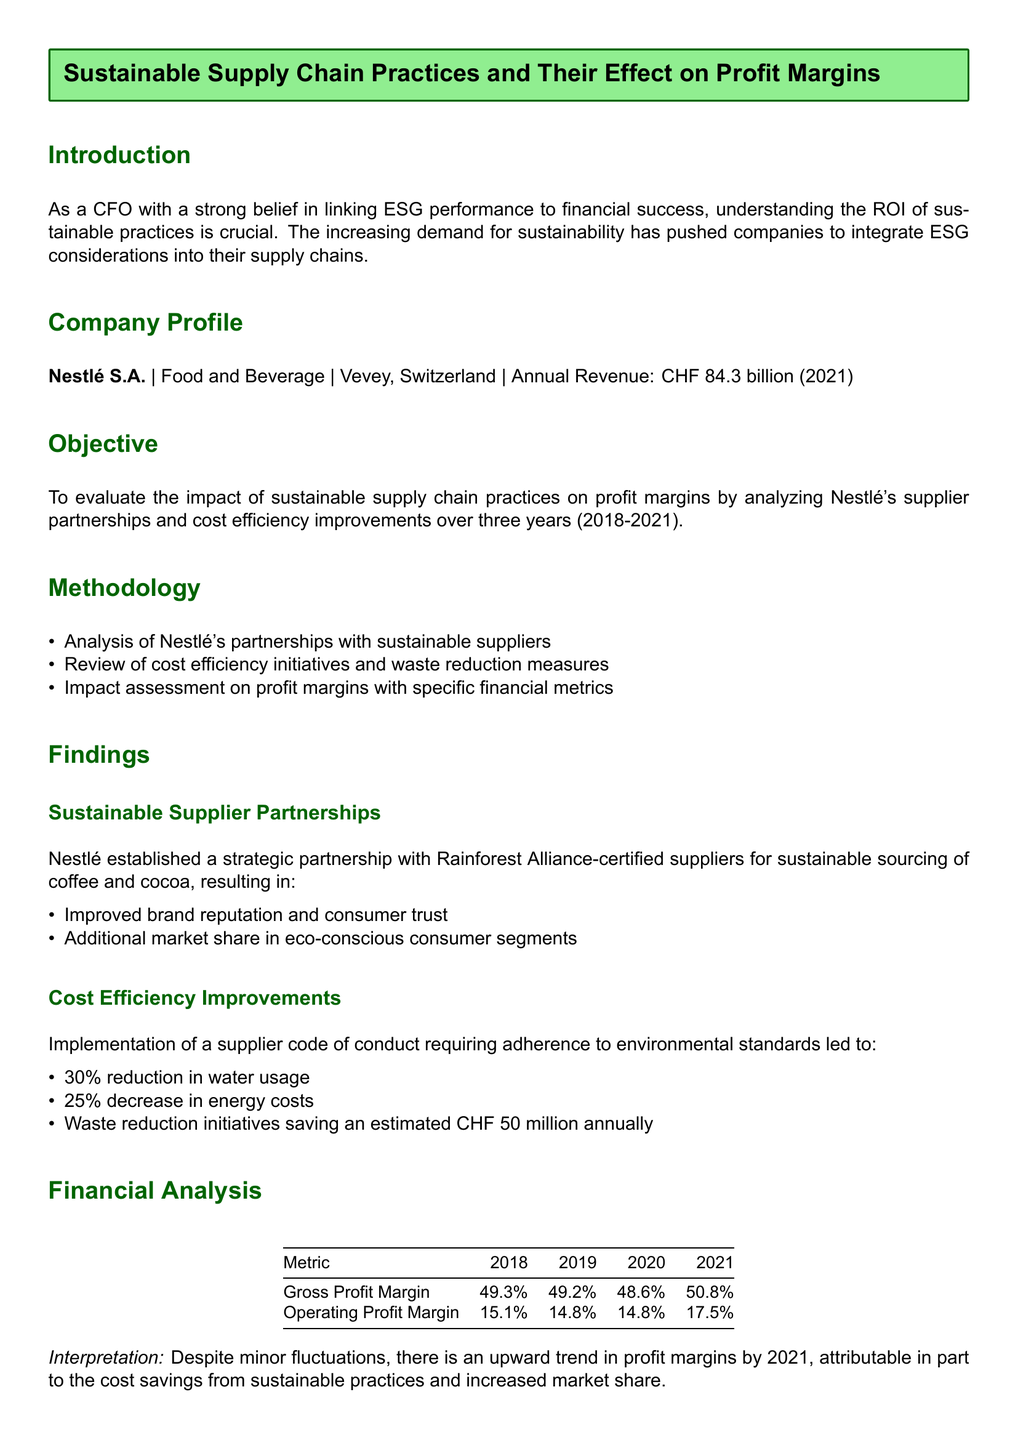What is the annual revenue of Nestlé in 2021? The document states the annual revenue of Nestlé in 2021 as CHF 84.3 billion.
Answer: CHF 84.3 billion What year marks the start of the evaluation period? The evaluation period for the impact of sustainable supply chain practices starts in 2018.
Answer: 2018 What percentage was the gross profit margin in 2021? The gross profit margin in 2021 is presented as 50.8%.
Answer: 50.8% What initiative led to a 30% reduction in water usage? The supplier code of conduct requiring adherence to environmental standards resulted in the 30% reduction in water usage.
Answer: Supplier code of conduct What is the estimated annual saving from waste reduction initiatives? The estimated annual savings from waste reduction initiatives is CHF 50 million.
Answer: CHF 50 million How much did the operating profit margin increase from 2020 to 2021? The operating profit margin increased from 14.8% in 2020 to 17.5% in 2021, indicating an increase of 2.7%.
Answer: 2.7% What strategy contributed to improving brand reputation and consumer trust? Establishing partnerships with Rainforest Alliance-certified suppliers contributed to improving brand reputation and consumer trust.
Answer: Partnerships with Rainforest Alliance-certified suppliers What is the effect of sustainable practices on Nestlé's profit margins? The conclusion notes that Nestlé's sustainable practices positively impacted its profit margins.
Answer: Positively impacted What is one of the recommendations for Nestlé regarding sustainable practices? One recommendation is to continue investing in sustainable supplier partnerships.
Answer: Continue investing in sustainable supplier partnerships 